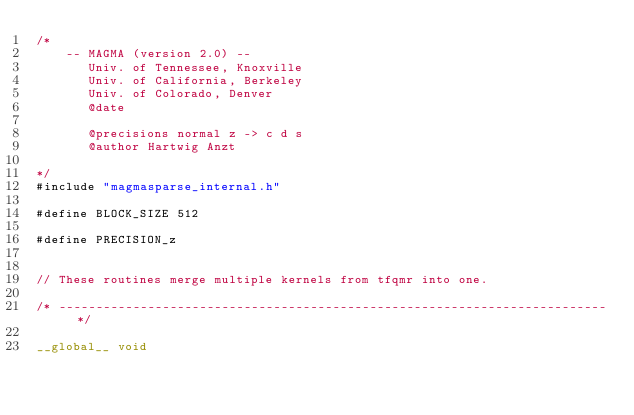Convert code to text. <code><loc_0><loc_0><loc_500><loc_500><_Cuda_>/*
    -- MAGMA (version 2.0) --
       Univ. of Tennessee, Knoxville
       Univ. of California, Berkeley
       Univ. of Colorado, Denver
       @date

       @precisions normal z -> c d s
       @author Hartwig Anzt

*/
#include "magmasparse_internal.h"

#define BLOCK_SIZE 512

#define PRECISION_z


// These routines merge multiple kernels from tfqmr into one.

/* -------------------------------------------------------------------------- */

__global__ void</code> 